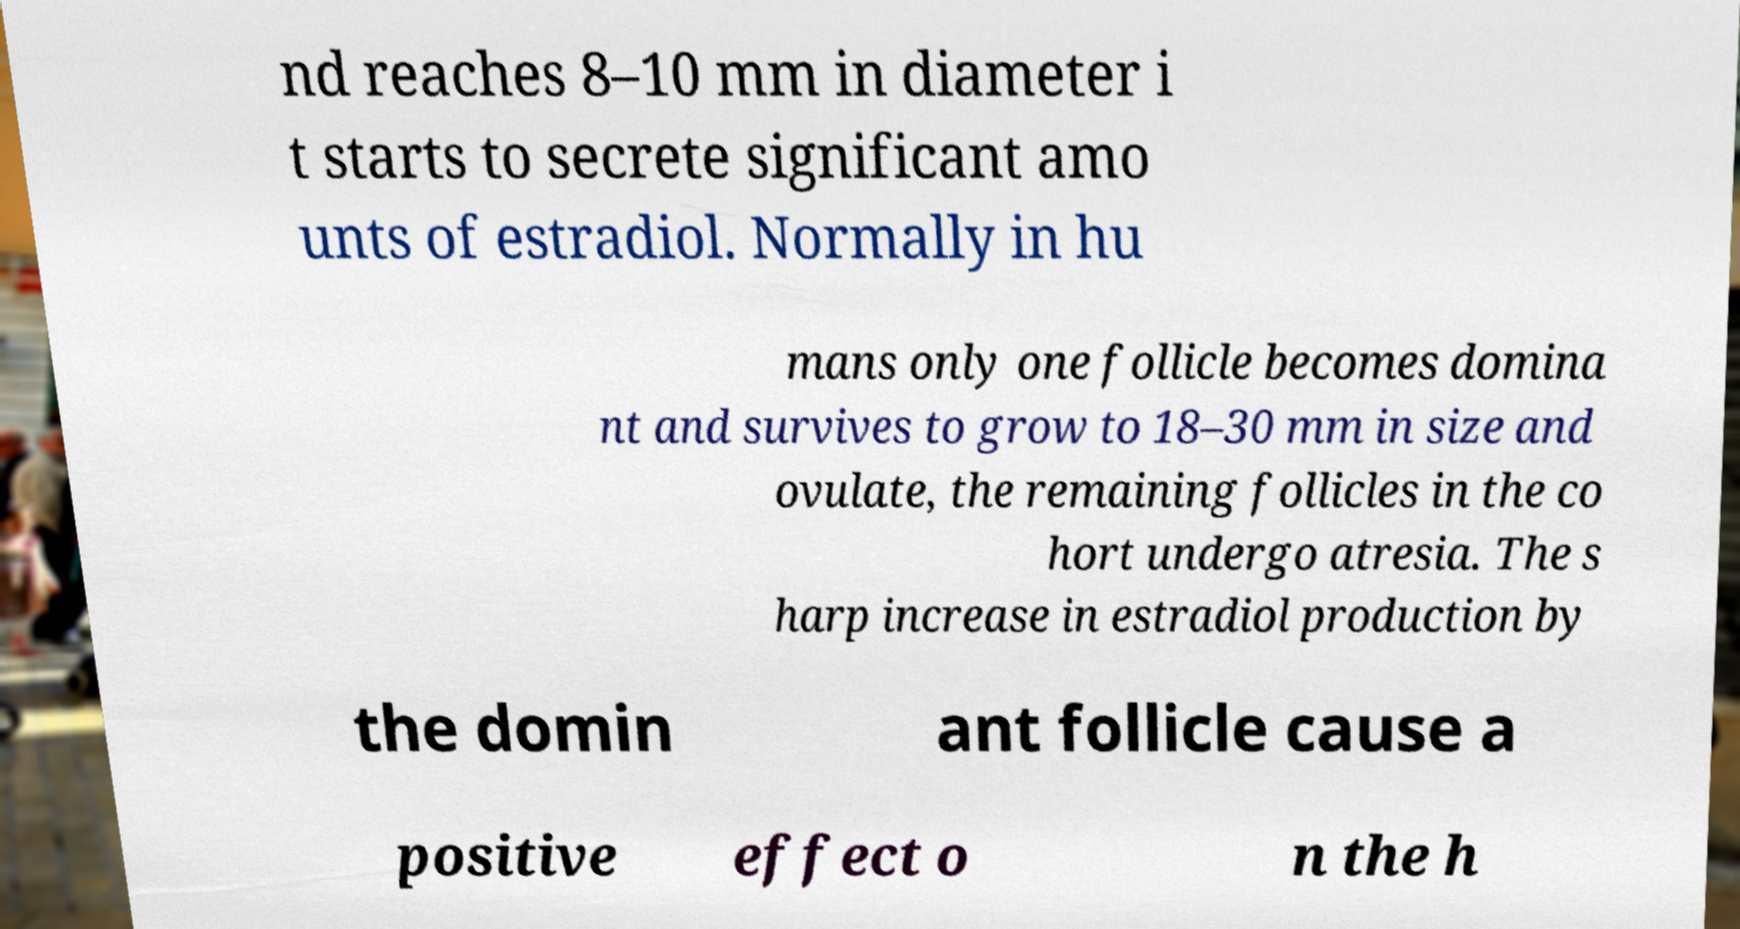Can you accurately transcribe the text from the provided image for me? nd reaches 8–10 mm in diameter i t starts to secrete significant amo unts of estradiol. Normally in hu mans only one follicle becomes domina nt and survives to grow to 18–30 mm in size and ovulate, the remaining follicles in the co hort undergo atresia. The s harp increase in estradiol production by the domin ant follicle cause a positive effect o n the h 